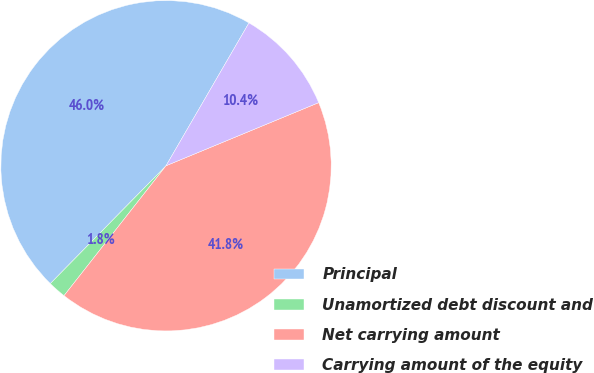Convert chart to OTSL. <chart><loc_0><loc_0><loc_500><loc_500><pie_chart><fcel>Principal<fcel>Unamortized debt discount and<fcel>Net carrying amount<fcel>Carrying amount of the equity<nl><fcel>46.02%<fcel>1.76%<fcel>41.84%<fcel>10.39%<nl></chart> 